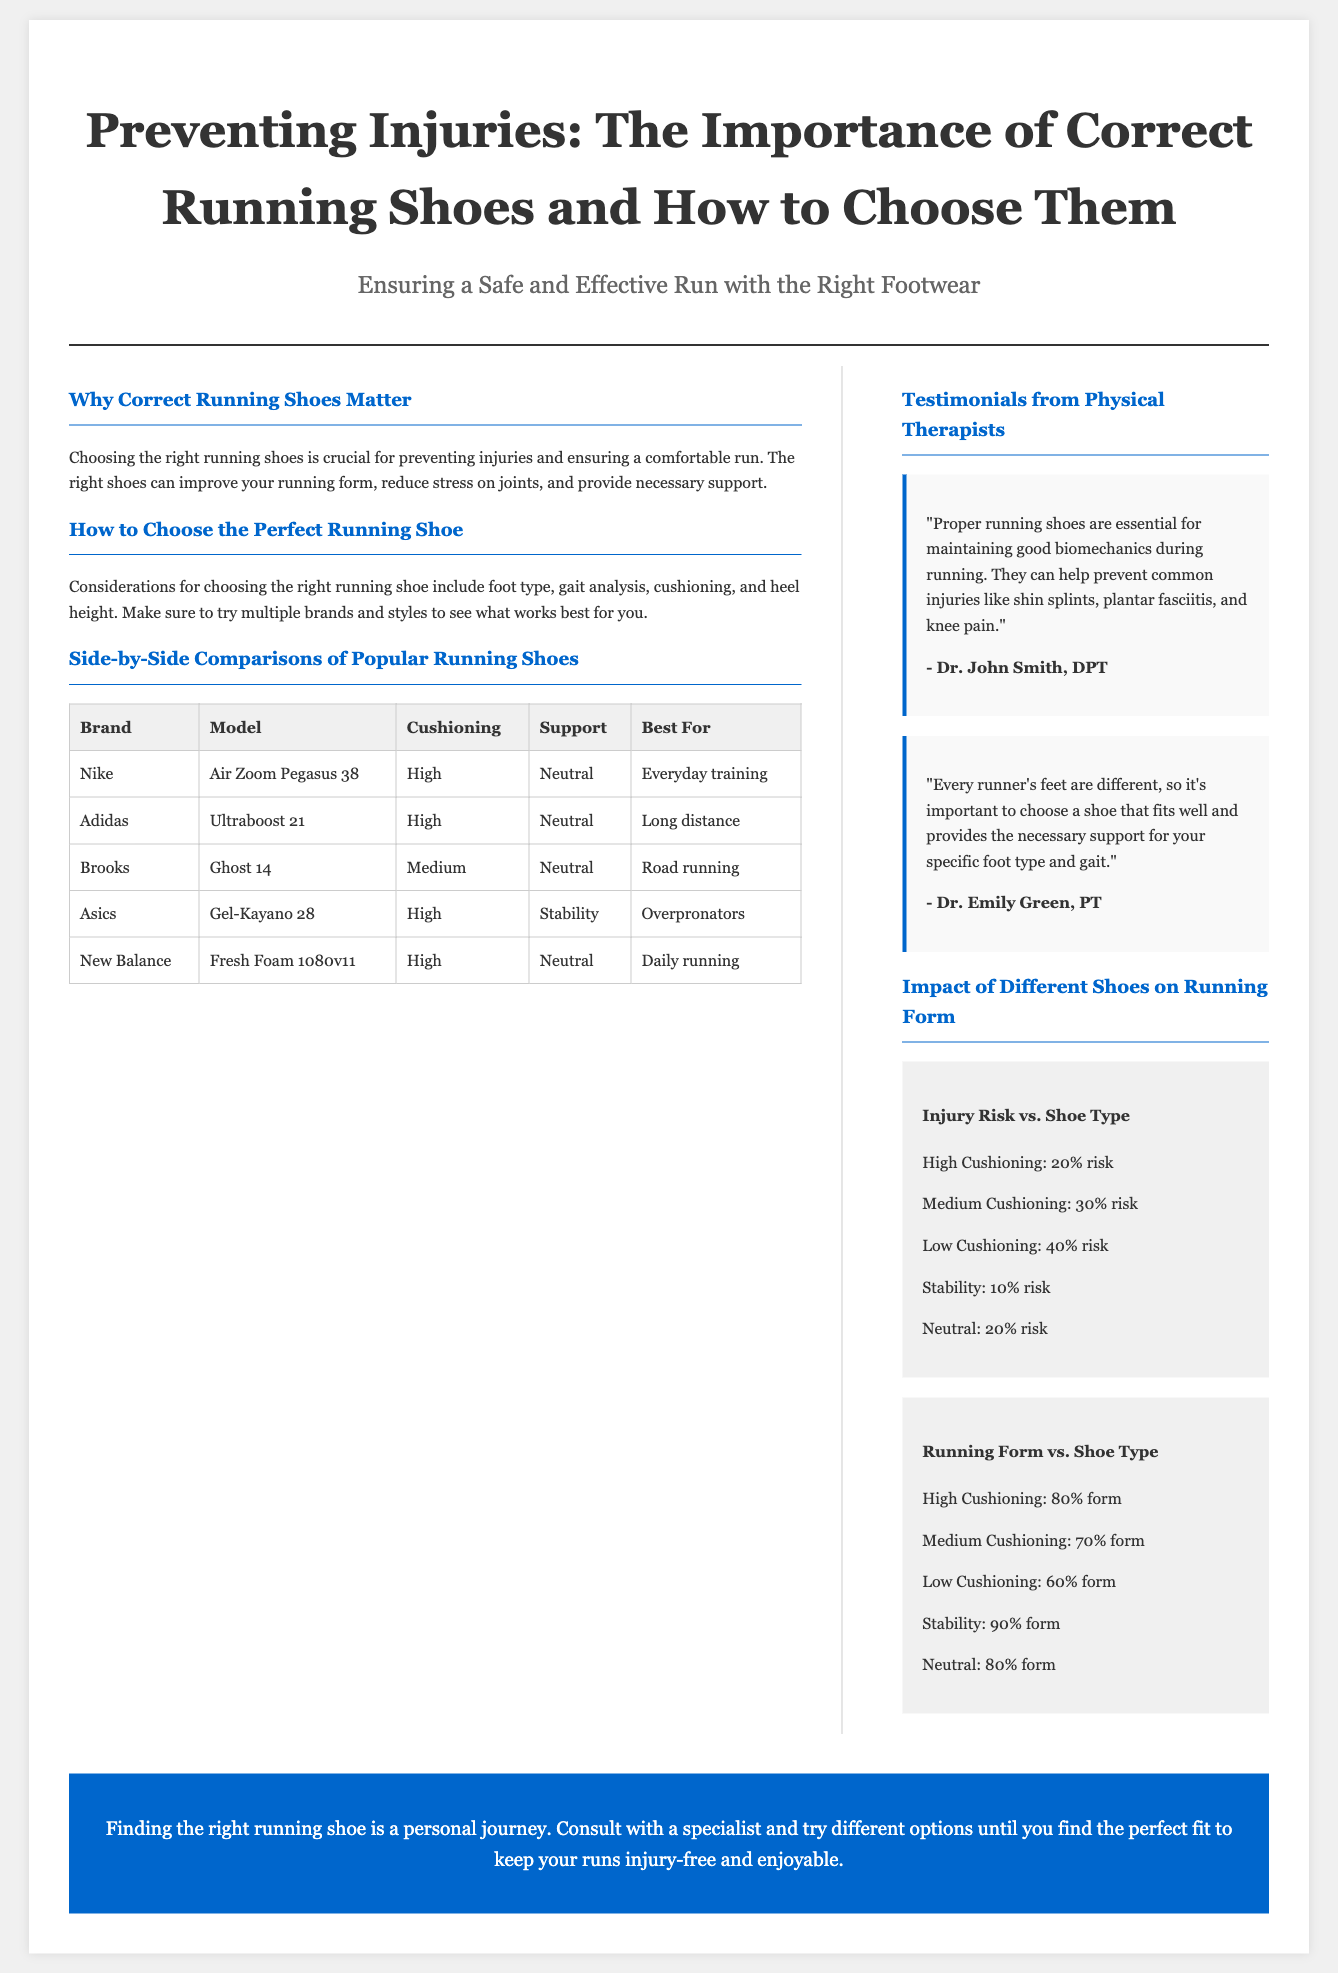What is the title of the article? The title of the article is prominently displayed in the header section of the document.
Answer: Preventing Injuries: The Importance of Correct Running Shoes and How to Choose Them Which shoe is recommended for overpronators? The recommendation for overpronators is found in the side-by-side comparisons of popular running shoes.
Answer: Gel-Kayano 28 What type of cushioning does the Ultraboost 21 have? The cushioning details for the Ultraboost 21 are listed in the comparison table.
Answer: High Who is quoted in the testimonial about maintaining good biomechanics? The testimonial section features quotes from various physical therapists including the specific person associated with the biomechanics statement.
Answer: Dr. John Smith What is the injury risk percentage for shoes with low cushioning? This information is provided in the chart showing the impact of different shoes on injury risk.
Answer: 40% risk What is the running form percentage for stability shoes? The chart detailing running form versus shoe type provides this specific percentage.
Answer: 90% form What is the best use case for the Air Zoom Pegasus 38? This answer can be found in the table that outlines the best use cases for each shoe model.
Answer: Everyday training Who emphasizes the importance of individual fitting for running shoes? A specific expert offers insights on individualized fitting in the testimonials section.
Answer: Dr. Emily Green What color is used for the header background? The design elements of the document can be evaluated for specific color choices used in various sections.
Answer: None (header has no color specified) 